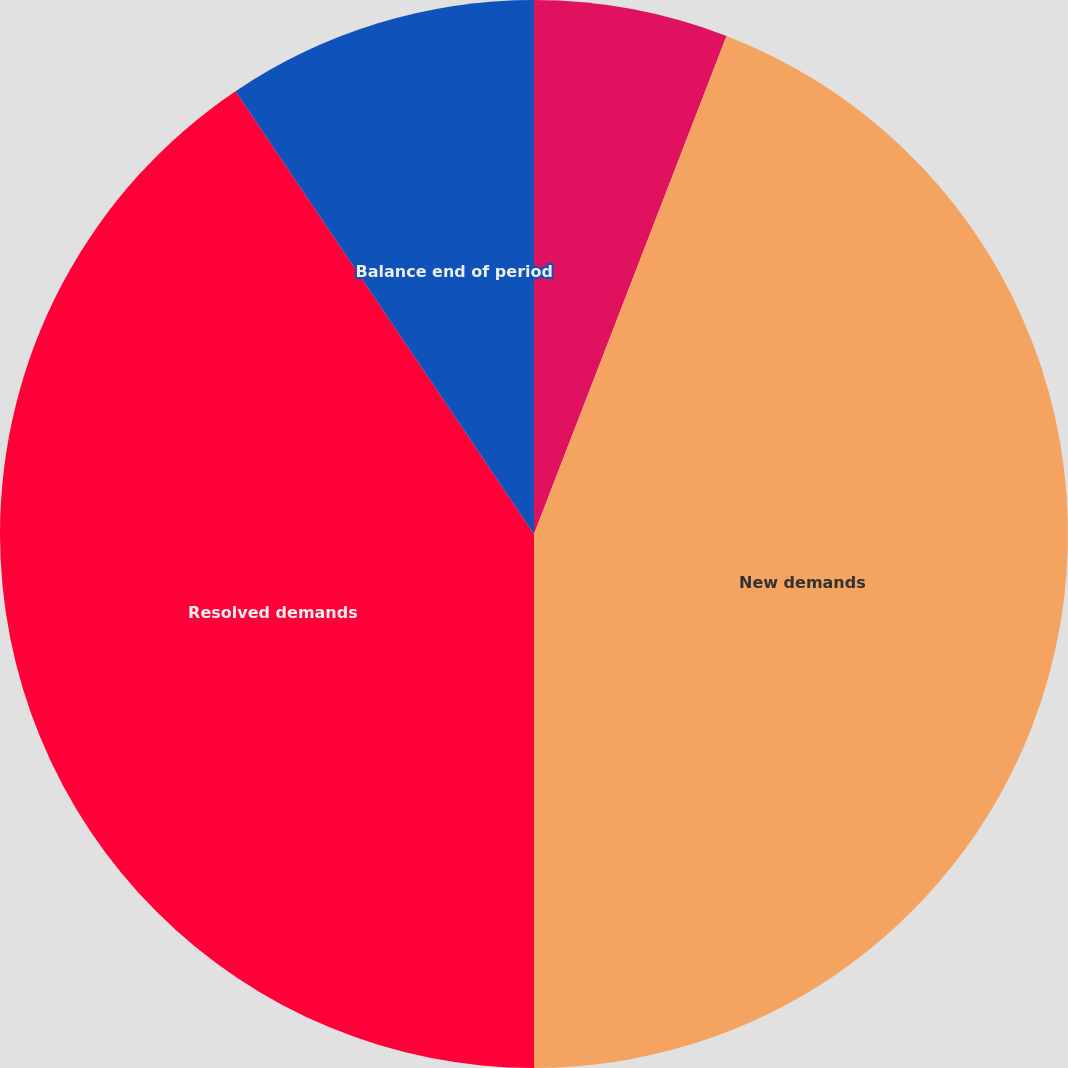<chart> <loc_0><loc_0><loc_500><loc_500><pie_chart><fcel>Balance beginning of period<fcel>New demands<fcel>Resolved demands<fcel>Balance end of period<nl><fcel>5.87%<fcel>44.13%<fcel>40.56%<fcel>9.44%<nl></chart> 